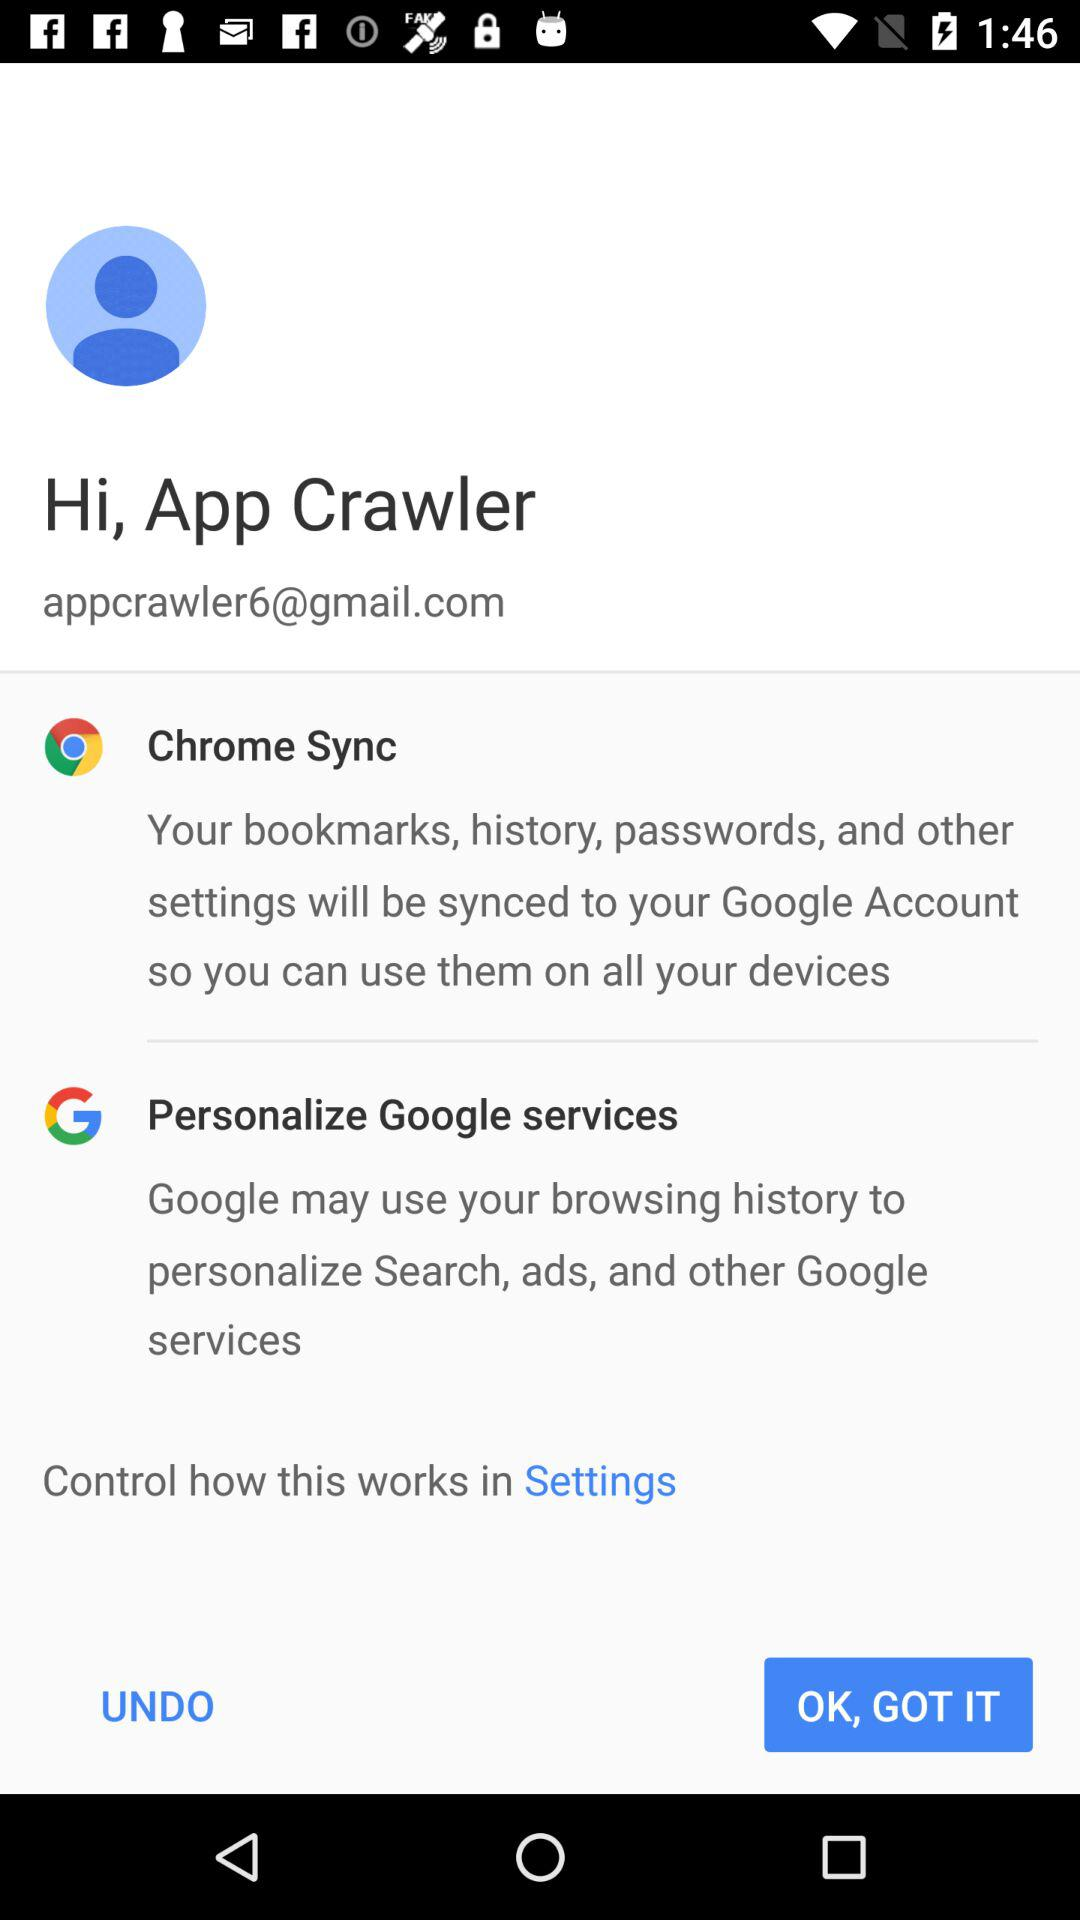Which feature is used by Google services to personalize search and ads? The feature used by Google services to personalize search and ads is browsing history. 